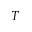<formula> <loc_0><loc_0><loc_500><loc_500>T</formula> 